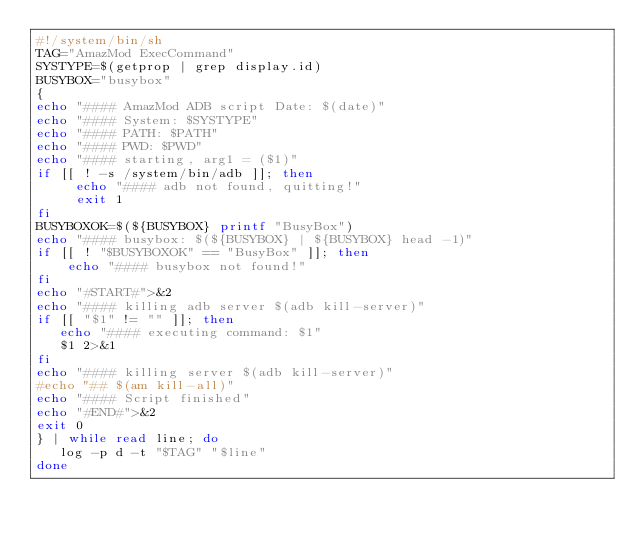<code> <loc_0><loc_0><loc_500><loc_500><_Bash_>#!/system/bin/sh
TAG="AmazMod ExecCommand"
SYSTYPE=$(getprop | grep display.id)
BUSYBOX="busybox"
{
echo "#### AmazMod ADB script Date: $(date)"
echo "#### System: $SYSTYPE"
echo "#### PATH: $PATH"
echo "#### PWD: $PWD"
echo "#### starting, arg1 = ($1)"
if [[ ! -s /system/bin/adb ]]; then
     echo "#### adb not found, quitting!"
     exit 1
fi
BUSYBOXOK=$(${BUSYBOX} printf "BusyBox")
echo "#### busybox: $(${BUSYBOX} | ${BUSYBOX} head -1)"
if [[ ! "$BUSYBOXOK" == "BusyBox" ]]; then
    echo "#### busybox not found!"
fi
echo "#START#">&2
echo "#### killing adb server $(adb kill-server)"
if [[ "$1" != "" ]]; then
   echo "#### executing command: $1"
   $1 2>&1
fi
echo "#### killing server $(adb kill-server)"
#echo "## $(am kill-all)"
echo "#### Script finished"
echo "#END#">&2
exit 0
} | while read line; do
   log -p d -t "$TAG" "$line"
done
</code> 